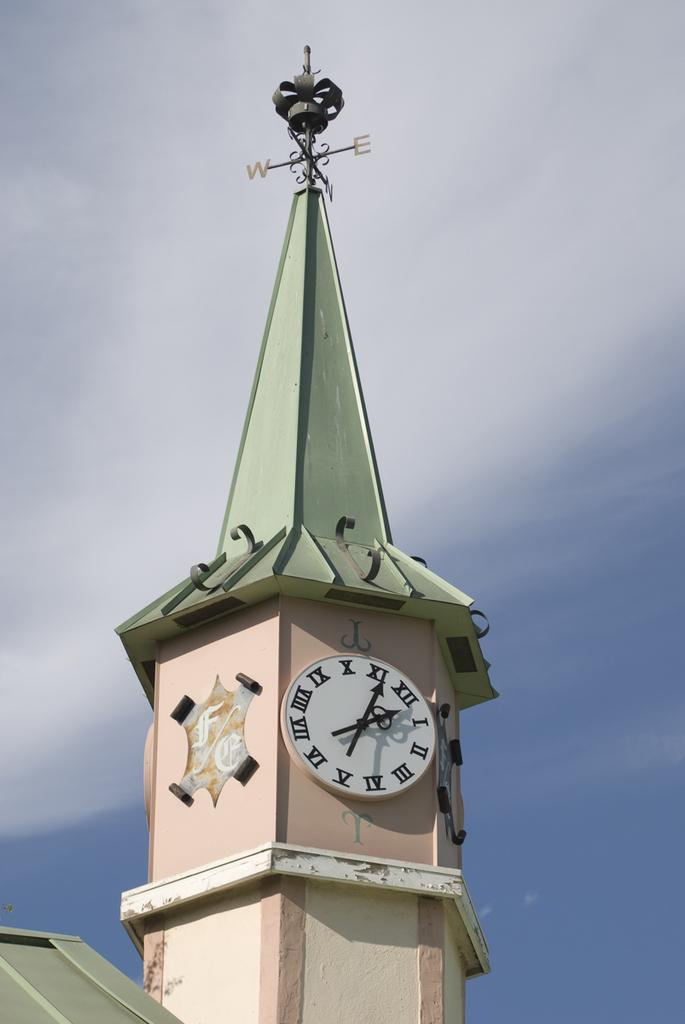<image>
Create a compact narrative representing the image presented. A clock on a pink tower that shows it to be five after two. 